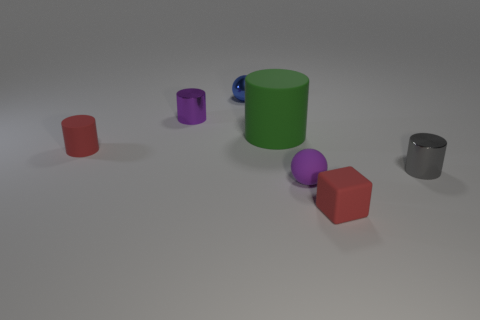What colors are the non-cylindrical objects in this image? The non-cylindrical objects in the image are red and gray. There are two red cubes and one gray cylinder. 